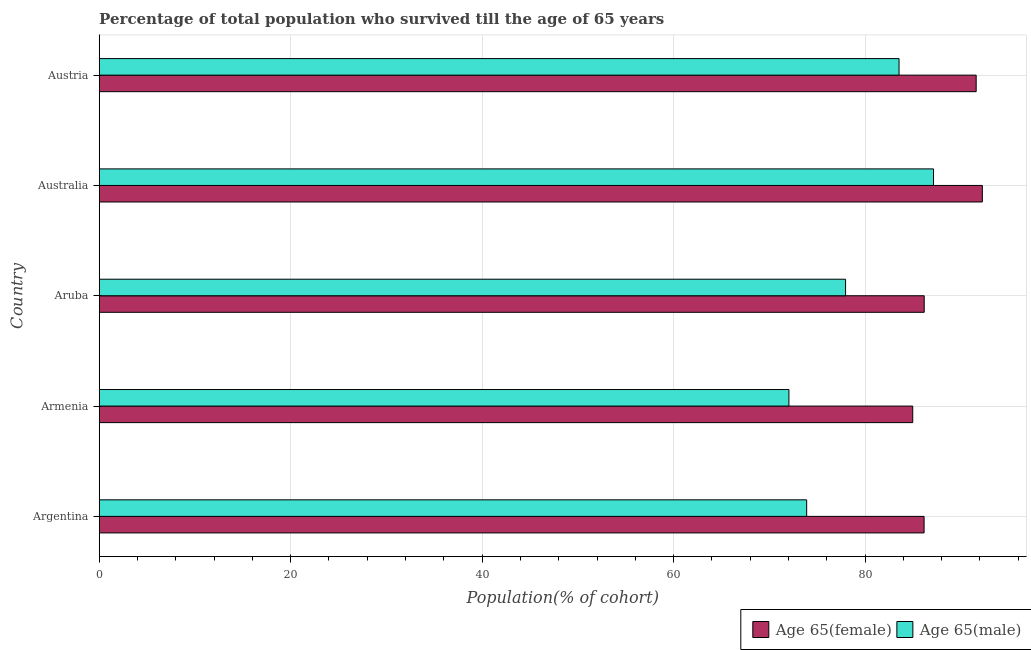Are the number of bars per tick equal to the number of legend labels?
Offer a very short reply. Yes. What is the label of the 5th group of bars from the top?
Provide a succinct answer. Argentina. In how many cases, is the number of bars for a given country not equal to the number of legend labels?
Provide a succinct answer. 0. What is the percentage of female population who survived till age of 65 in Australia?
Offer a very short reply. 92.25. Across all countries, what is the maximum percentage of female population who survived till age of 65?
Give a very brief answer. 92.25. Across all countries, what is the minimum percentage of female population who survived till age of 65?
Your response must be concise. 84.98. In which country was the percentage of male population who survived till age of 65 minimum?
Ensure brevity in your answer.  Armenia. What is the total percentage of female population who survived till age of 65 in the graph?
Ensure brevity in your answer.  441.18. What is the difference between the percentage of male population who survived till age of 65 in Argentina and that in Australia?
Provide a short and direct response. -13.25. What is the difference between the percentage of male population who survived till age of 65 in Australia and the percentage of female population who survived till age of 65 in Aruba?
Keep it short and to the point. 0.97. What is the average percentage of male population who survived till age of 65 per country?
Your answer should be very brief. 78.92. What is the difference between the percentage of female population who survived till age of 65 and percentage of male population who survived till age of 65 in Aruba?
Your answer should be compact. 8.22. In how many countries, is the percentage of male population who survived till age of 65 greater than 28 %?
Give a very brief answer. 5. What is the ratio of the percentage of female population who survived till age of 65 in Aruba to that in Australia?
Your answer should be very brief. 0.93. Is the percentage of female population who survived till age of 65 in Aruba less than that in Austria?
Keep it short and to the point. Yes. What is the difference between the highest and the second highest percentage of female population who survived till age of 65?
Your answer should be compact. 0.64. What is the difference between the highest and the lowest percentage of female population who survived till age of 65?
Provide a succinct answer. 7.27. In how many countries, is the percentage of female population who survived till age of 65 greater than the average percentage of female population who survived till age of 65 taken over all countries?
Your answer should be very brief. 2. What does the 1st bar from the top in Argentina represents?
Your response must be concise. Age 65(male). What does the 2nd bar from the bottom in Austria represents?
Ensure brevity in your answer.  Age 65(male). Are all the bars in the graph horizontal?
Ensure brevity in your answer.  Yes. Are the values on the major ticks of X-axis written in scientific E-notation?
Your answer should be compact. No. Does the graph contain grids?
Keep it short and to the point. Yes. How many legend labels are there?
Keep it short and to the point. 2. What is the title of the graph?
Your answer should be compact. Percentage of total population who survived till the age of 65 years. What is the label or title of the X-axis?
Your answer should be very brief. Population(% of cohort). What is the Population(% of cohort) of Age 65(female) in Argentina?
Keep it short and to the point. 86.17. What is the Population(% of cohort) of Age 65(male) in Argentina?
Your answer should be compact. 73.9. What is the Population(% of cohort) of Age 65(female) in Armenia?
Provide a succinct answer. 84.98. What is the Population(% of cohort) in Age 65(male) in Armenia?
Provide a succinct answer. 72.05. What is the Population(% of cohort) in Age 65(female) in Aruba?
Provide a short and direct response. 86.18. What is the Population(% of cohort) of Age 65(male) in Aruba?
Your answer should be compact. 77.96. What is the Population(% of cohort) in Age 65(female) in Australia?
Your answer should be compact. 92.25. What is the Population(% of cohort) of Age 65(male) in Australia?
Offer a terse response. 87.15. What is the Population(% of cohort) in Age 65(female) in Austria?
Make the answer very short. 91.61. What is the Population(% of cohort) of Age 65(male) in Austria?
Ensure brevity in your answer.  83.55. Across all countries, what is the maximum Population(% of cohort) of Age 65(female)?
Offer a very short reply. 92.25. Across all countries, what is the maximum Population(% of cohort) of Age 65(male)?
Your response must be concise. 87.15. Across all countries, what is the minimum Population(% of cohort) of Age 65(female)?
Your answer should be very brief. 84.98. Across all countries, what is the minimum Population(% of cohort) in Age 65(male)?
Your response must be concise. 72.05. What is the total Population(% of cohort) in Age 65(female) in the graph?
Your answer should be compact. 441.18. What is the total Population(% of cohort) of Age 65(male) in the graph?
Your response must be concise. 394.61. What is the difference between the Population(% of cohort) of Age 65(female) in Argentina and that in Armenia?
Provide a short and direct response. 1.19. What is the difference between the Population(% of cohort) in Age 65(male) in Argentina and that in Armenia?
Ensure brevity in your answer.  1.85. What is the difference between the Population(% of cohort) in Age 65(female) in Argentina and that in Aruba?
Offer a terse response. -0.01. What is the difference between the Population(% of cohort) in Age 65(male) in Argentina and that in Aruba?
Ensure brevity in your answer.  -4.06. What is the difference between the Population(% of cohort) in Age 65(female) in Argentina and that in Australia?
Your response must be concise. -6.08. What is the difference between the Population(% of cohort) in Age 65(male) in Argentina and that in Australia?
Offer a very short reply. -13.25. What is the difference between the Population(% of cohort) in Age 65(female) in Argentina and that in Austria?
Your answer should be very brief. -5.44. What is the difference between the Population(% of cohort) of Age 65(male) in Argentina and that in Austria?
Ensure brevity in your answer.  -9.65. What is the difference between the Population(% of cohort) of Age 65(female) in Armenia and that in Aruba?
Your answer should be compact. -1.2. What is the difference between the Population(% of cohort) of Age 65(male) in Armenia and that in Aruba?
Your response must be concise. -5.92. What is the difference between the Population(% of cohort) of Age 65(female) in Armenia and that in Australia?
Keep it short and to the point. -7.27. What is the difference between the Population(% of cohort) in Age 65(male) in Armenia and that in Australia?
Ensure brevity in your answer.  -15.1. What is the difference between the Population(% of cohort) of Age 65(female) in Armenia and that in Austria?
Offer a terse response. -6.63. What is the difference between the Population(% of cohort) in Age 65(male) in Armenia and that in Austria?
Your answer should be very brief. -11.5. What is the difference between the Population(% of cohort) of Age 65(female) in Aruba and that in Australia?
Your response must be concise. -6.07. What is the difference between the Population(% of cohort) of Age 65(male) in Aruba and that in Australia?
Ensure brevity in your answer.  -9.19. What is the difference between the Population(% of cohort) of Age 65(female) in Aruba and that in Austria?
Your response must be concise. -5.43. What is the difference between the Population(% of cohort) in Age 65(male) in Aruba and that in Austria?
Provide a short and direct response. -5.59. What is the difference between the Population(% of cohort) of Age 65(female) in Australia and that in Austria?
Your answer should be compact. 0.64. What is the difference between the Population(% of cohort) of Age 65(male) in Australia and that in Austria?
Your answer should be compact. 3.6. What is the difference between the Population(% of cohort) of Age 65(female) in Argentina and the Population(% of cohort) of Age 65(male) in Armenia?
Give a very brief answer. 14.12. What is the difference between the Population(% of cohort) of Age 65(female) in Argentina and the Population(% of cohort) of Age 65(male) in Aruba?
Make the answer very short. 8.2. What is the difference between the Population(% of cohort) of Age 65(female) in Argentina and the Population(% of cohort) of Age 65(male) in Australia?
Your response must be concise. -0.98. What is the difference between the Population(% of cohort) in Age 65(female) in Argentina and the Population(% of cohort) in Age 65(male) in Austria?
Make the answer very short. 2.62. What is the difference between the Population(% of cohort) of Age 65(female) in Armenia and the Population(% of cohort) of Age 65(male) in Aruba?
Give a very brief answer. 7.02. What is the difference between the Population(% of cohort) of Age 65(female) in Armenia and the Population(% of cohort) of Age 65(male) in Australia?
Your answer should be very brief. -2.17. What is the difference between the Population(% of cohort) in Age 65(female) in Armenia and the Population(% of cohort) in Age 65(male) in Austria?
Your response must be concise. 1.43. What is the difference between the Population(% of cohort) of Age 65(female) in Aruba and the Population(% of cohort) of Age 65(male) in Australia?
Your answer should be very brief. -0.97. What is the difference between the Population(% of cohort) of Age 65(female) in Aruba and the Population(% of cohort) of Age 65(male) in Austria?
Offer a terse response. 2.63. What is the difference between the Population(% of cohort) of Age 65(female) in Australia and the Population(% of cohort) of Age 65(male) in Austria?
Ensure brevity in your answer.  8.7. What is the average Population(% of cohort) of Age 65(female) per country?
Provide a succinct answer. 88.24. What is the average Population(% of cohort) in Age 65(male) per country?
Keep it short and to the point. 78.92. What is the difference between the Population(% of cohort) of Age 65(female) and Population(% of cohort) of Age 65(male) in Argentina?
Keep it short and to the point. 12.27. What is the difference between the Population(% of cohort) in Age 65(female) and Population(% of cohort) in Age 65(male) in Armenia?
Ensure brevity in your answer.  12.93. What is the difference between the Population(% of cohort) of Age 65(female) and Population(% of cohort) of Age 65(male) in Aruba?
Your response must be concise. 8.22. What is the difference between the Population(% of cohort) in Age 65(female) and Population(% of cohort) in Age 65(male) in Australia?
Your answer should be very brief. 5.1. What is the difference between the Population(% of cohort) in Age 65(female) and Population(% of cohort) in Age 65(male) in Austria?
Offer a terse response. 8.06. What is the ratio of the Population(% of cohort) of Age 65(female) in Argentina to that in Armenia?
Make the answer very short. 1.01. What is the ratio of the Population(% of cohort) of Age 65(male) in Argentina to that in Armenia?
Provide a succinct answer. 1.03. What is the ratio of the Population(% of cohort) in Age 65(female) in Argentina to that in Aruba?
Keep it short and to the point. 1. What is the ratio of the Population(% of cohort) in Age 65(male) in Argentina to that in Aruba?
Make the answer very short. 0.95. What is the ratio of the Population(% of cohort) in Age 65(female) in Argentina to that in Australia?
Provide a succinct answer. 0.93. What is the ratio of the Population(% of cohort) in Age 65(male) in Argentina to that in Australia?
Provide a succinct answer. 0.85. What is the ratio of the Population(% of cohort) in Age 65(female) in Argentina to that in Austria?
Offer a very short reply. 0.94. What is the ratio of the Population(% of cohort) of Age 65(male) in Argentina to that in Austria?
Your answer should be compact. 0.88. What is the ratio of the Population(% of cohort) in Age 65(female) in Armenia to that in Aruba?
Make the answer very short. 0.99. What is the ratio of the Population(% of cohort) of Age 65(male) in Armenia to that in Aruba?
Provide a succinct answer. 0.92. What is the ratio of the Population(% of cohort) of Age 65(female) in Armenia to that in Australia?
Your answer should be very brief. 0.92. What is the ratio of the Population(% of cohort) in Age 65(male) in Armenia to that in Australia?
Offer a terse response. 0.83. What is the ratio of the Population(% of cohort) of Age 65(female) in Armenia to that in Austria?
Provide a short and direct response. 0.93. What is the ratio of the Population(% of cohort) of Age 65(male) in Armenia to that in Austria?
Offer a very short reply. 0.86. What is the ratio of the Population(% of cohort) in Age 65(female) in Aruba to that in Australia?
Keep it short and to the point. 0.93. What is the ratio of the Population(% of cohort) of Age 65(male) in Aruba to that in Australia?
Your answer should be compact. 0.89. What is the ratio of the Population(% of cohort) in Age 65(female) in Aruba to that in Austria?
Provide a short and direct response. 0.94. What is the ratio of the Population(% of cohort) in Age 65(male) in Aruba to that in Austria?
Make the answer very short. 0.93. What is the ratio of the Population(% of cohort) of Age 65(male) in Australia to that in Austria?
Provide a short and direct response. 1.04. What is the difference between the highest and the second highest Population(% of cohort) in Age 65(female)?
Your answer should be compact. 0.64. What is the difference between the highest and the second highest Population(% of cohort) in Age 65(male)?
Offer a very short reply. 3.6. What is the difference between the highest and the lowest Population(% of cohort) of Age 65(female)?
Give a very brief answer. 7.27. What is the difference between the highest and the lowest Population(% of cohort) in Age 65(male)?
Keep it short and to the point. 15.1. 